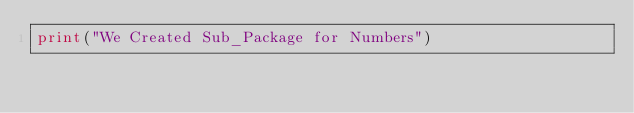<code> <loc_0><loc_0><loc_500><loc_500><_Python_>print("We Created Sub_Package for Numbers")
</code> 